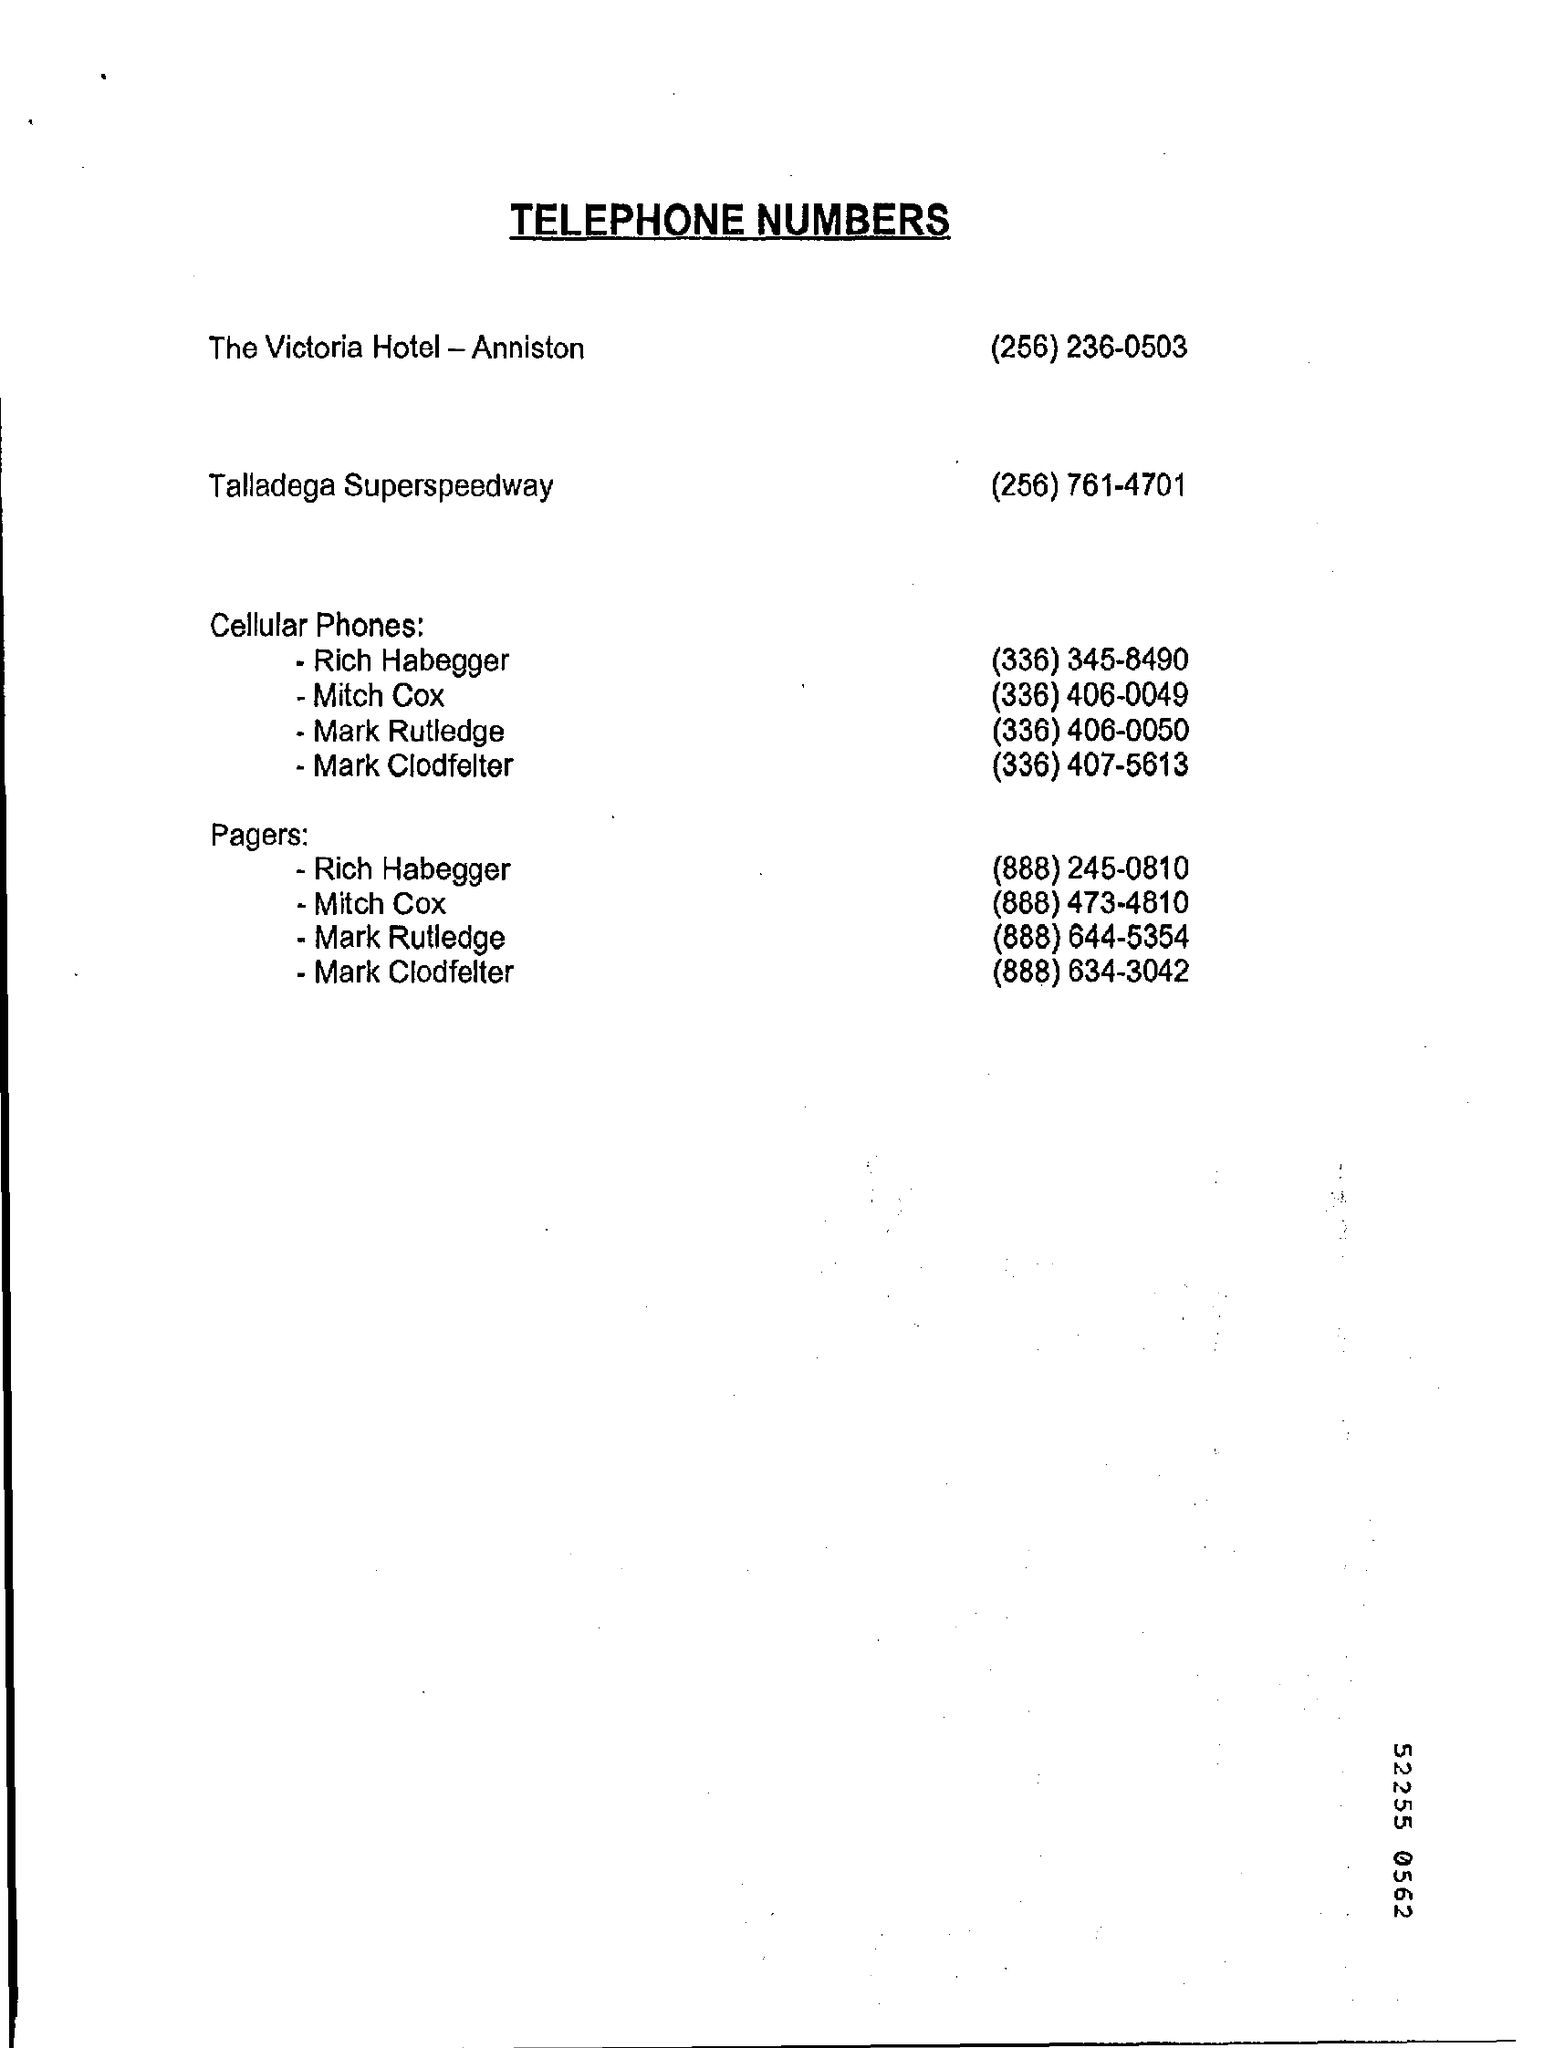Title of the document?
Ensure brevity in your answer.  Telephone Numbers. 